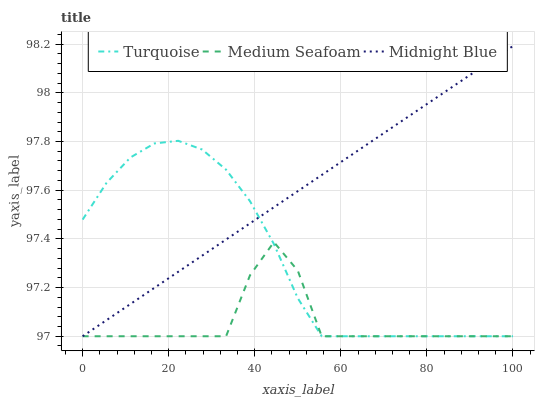Does Medium Seafoam have the minimum area under the curve?
Answer yes or no. Yes. Does Midnight Blue have the maximum area under the curve?
Answer yes or no. Yes. Does Midnight Blue have the minimum area under the curve?
Answer yes or no. No. Does Medium Seafoam have the maximum area under the curve?
Answer yes or no. No. Is Midnight Blue the smoothest?
Answer yes or no. Yes. Is Medium Seafoam the roughest?
Answer yes or no. Yes. Is Medium Seafoam the smoothest?
Answer yes or no. No. Is Midnight Blue the roughest?
Answer yes or no. No. Does Midnight Blue have the highest value?
Answer yes or no. Yes. Does Medium Seafoam have the highest value?
Answer yes or no. No. Does Turquoise intersect Medium Seafoam?
Answer yes or no. Yes. Is Turquoise less than Medium Seafoam?
Answer yes or no. No. Is Turquoise greater than Medium Seafoam?
Answer yes or no. No. 